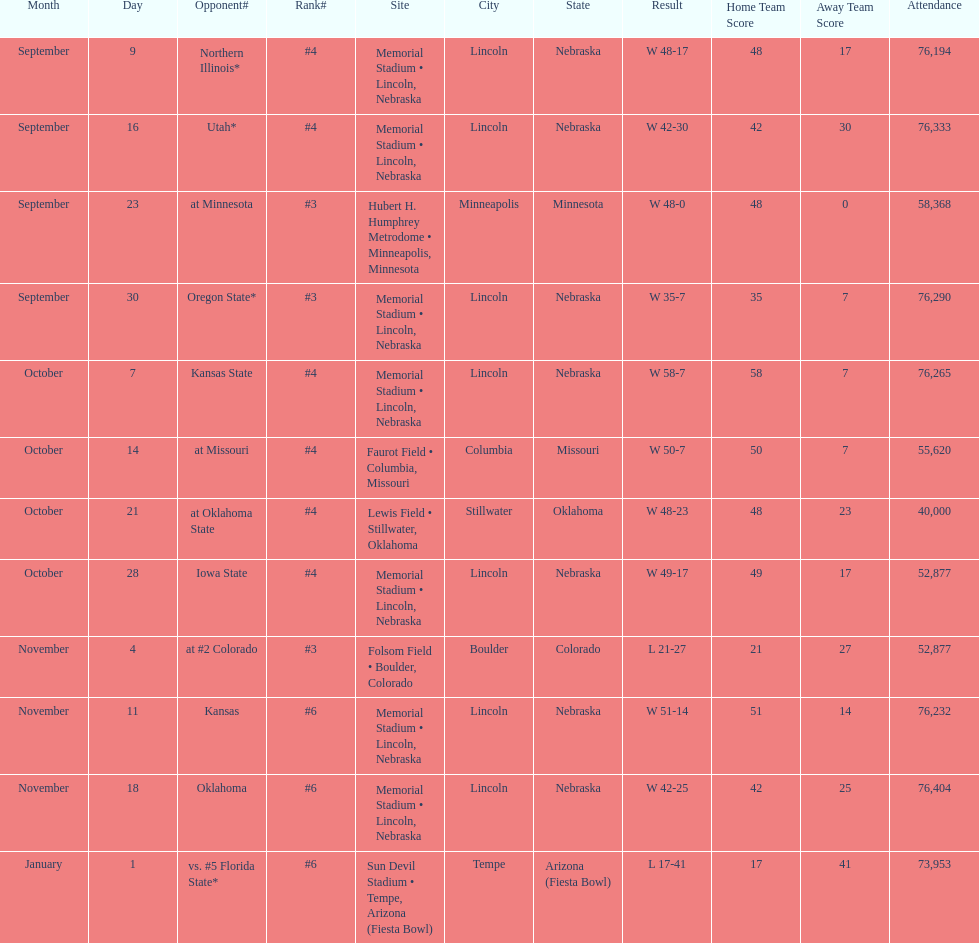What's the number of people who attended the oregon state game? 76,290. 